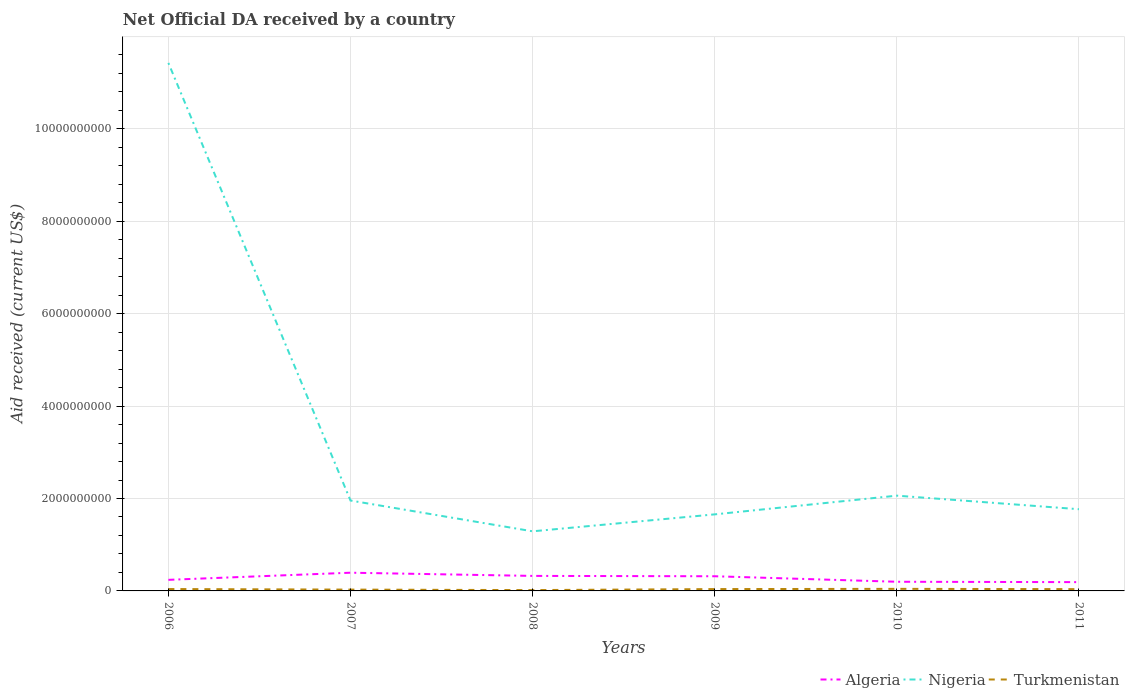How many different coloured lines are there?
Ensure brevity in your answer.  3. Does the line corresponding to Nigeria intersect with the line corresponding to Algeria?
Your answer should be compact. No. Across all years, what is the maximum net official development assistance aid received in Nigeria?
Give a very brief answer. 1.29e+09. What is the total net official development assistance aid received in Algeria in the graph?
Provide a succinct answer. 1.35e+08. What is the difference between the highest and the second highest net official development assistance aid received in Turkmenistan?
Your answer should be compact. 2.65e+07. What is the difference between two consecutive major ticks on the Y-axis?
Offer a very short reply. 2.00e+09. How many legend labels are there?
Keep it short and to the point. 3. How are the legend labels stacked?
Provide a short and direct response. Horizontal. What is the title of the graph?
Keep it short and to the point. Net Official DA received by a country. Does "Dominica" appear as one of the legend labels in the graph?
Ensure brevity in your answer.  No. What is the label or title of the Y-axis?
Provide a succinct answer. Aid received (current US$). What is the Aid received (current US$) of Algeria in 2006?
Your answer should be very brief. 2.40e+08. What is the Aid received (current US$) in Nigeria in 2006?
Offer a terse response. 1.14e+1. What is the Aid received (current US$) of Turkmenistan in 2006?
Your answer should be very brief. 4.07e+07. What is the Aid received (current US$) of Algeria in 2007?
Offer a very short reply. 3.94e+08. What is the Aid received (current US$) of Nigeria in 2007?
Your response must be concise. 1.96e+09. What is the Aid received (current US$) of Turkmenistan in 2007?
Provide a succinct answer. 2.85e+07. What is the Aid received (current US$) in Algeria in 2008?
Ensure brevity in your answer.  3.25e+08. What is the Aid received (current US$) of Nigeria in 2008?
Your answer should be very brief. 1.29e+09. What is the Aid received (current US$) in Turkmenistan in 2008?
Ensure brevity in your answer.  1.81e+07. What is the Aid received (current US$) in Algeria in 2009?
Offer a very short reply. 3.18e+08. What is the Aid received (current US$) of Nigeria in 2009?
Provide a succinct answer. 1.66e+09. What is the Aid received (current US$) in Turkmenistan in 2009?
Your answer should be compact. 3.98e+07. What is the Aid received (current US$) in Algeria in 2010?
Keep it short and to the point. 1.98e+08. What is the Aid received (current US$) of Nigeria in 2010?
Provide a succinct answer. 2.06e+09. What is the Aid received (current US$) in Turkmenistan in 2010?
Offer a terse response. 4.46e+07. What is the Aid received (current US$) in Algeria in 2011?
Offer a terse response. 1.90e+08. What is the Aid received (current US$) of Nigeria in 2011?
Your answer should be very brief. 1.77e+09. What is the Aid received (current US$) of Turkmenistan in 2011?
Provide a succinct answer. 3.87e+07. Across all years, what is the maximum Aid received (current US$) in Algeria?
Offer a very short reply. 3.94e+08. Across all years, what is the maximum Aid received (current US$) of Nigeria?
Make the answer very short. 1.14e+1. Across all years, what is the maximum Aid received (current US$) in Turkmenistan?
Offer a terse response. 4.46e+07. Across all years, what is the minimum Aid received (current US$) of Algeria?
Provide a succinct answer. 1.90e+08. Across all years, what is the minimum Aid received (current US$) in Nigeria?
Provide a succinct answer. 1.29e+09. Across all years, what is the minimum Aid received (current US$) of Turkmenistan?
Provide a short and direct response. 1.81e+07. What is the total Aid received (current US$) of Algeria in the graph?
Provide a short and direct response. 1.67e+09. What is the total Aid received (current US$) of Nigeria in the graph?
Offer a very short reply. 2.02e+1. What is the total Aid received (current US$) of Turkmenistan in the graph?
Keep it short and to the point. 2.10e+08. What is the difference between the Aid received (current US$) in Algeria in 2006 and that in 2007?
Your answer should be very brief. -1.54e+08. What is the difference between the Aid received (current US$) of Nigeria in 2006 and that in 2007?
Make the answer very short. 9.47e+09. What is the difference between the Aid received (current US$) of Turkmenistan in 2006 and that in 2007?
Keep it short and to the point. 1.22e+07. What is the difference between the Aid received (current US$) of Algeria in 2006 and that in 2008?
Keep it short and to the point. -8.51e+07. What is the difference between the Aid received (current US$) in Nigeria in 2006 and that in 2008?
Keep it short and to the point. 1.01e+1. What is the difference between the Aid received (current US$) in Turkmenistan in 2006 and that in 2008?
Ensure brevity in your answer.  2.26e+07. What is the difference between the Aid received (current US$) in Algeria in 2006 and that in 2009?
Offer a terse response. -7.76e+07. What is the difference between the Aid received (current US$) in Nigeria in 2006 and that in 2009?
Your response must be concise. 9.77e+09. What is the difference between the Aid received (current US$) in Turkmenistan in 2006 and that in 2009?
Give a very brief answer. 8.70e+05. What is the difference between the Aid received (current US$) of Algeria in 2006 and that in 2010?
Offer a very short reply. 4.16e+07. What is the difference between the Aid received (current US$) in Nigeria in 2006 and that in 2010?
Make the answer very short. 9.37e+09. What is the difference between the Aid received (current US$) in Turkmenistan in 2006 and that in 2010?
Provide a short and direct response. -3.94e+06. What is the difference between the Aid received (current US$) in Algeria in 2006 and that in 2011?
Give a very brief answer. 4.96e+07. What is the difference between the Aid received (current US$) in Nigeria in 2006 and that in 2011?
Give a very brief answer. 9.66e+09. What is the difference between the Aid received (current US$) in Turkmenistan in 2006 and that in 2011?
Offer a very short reply. 2.03e+06. What is the difference between the Aid received (current US$) in Algeria in 2007 and that in 2008?
Your answer should be compact. 6.92e+07. What is the difference between the Aid received (current US$) of Nigeria in 2007 and that in 2008?
Give a very brief answer. 6.66e+08. What is the difference between the Aid received (current US$) of Turkmenistan in 2007 and that in 2008?
Keep it short and to the point. 1.04e+07. What is the difference between the Aid received (current US$) of Algeria in 2007 and that in 2009?
Make the answer very short. 7.68e+07. What is the difference between the Aid received (current US$) of Nigeria in 2007 and that in 2009?
Make the answer very short. 2.99e+08. What is the difference between the Aid received (current US$) in Turkmenistan in 2007 and that in 2009?
Give a very brief answer. -1.14e+07. What is the difference between the Aid received (current US$) of Algeria in 2007 and that in 2010?
Offer a terse response. 1.96e+08. What is the difference between the Aid received (current US$) of Nigeria in 2007 and that in 2010?
Your response must be concise. -1.06e+08. What is the difference between the Aid received (current US$) in Turkmenistan in 2007 and that in 2010?
Provide a succinct answer. -1.62e+07. What is the difference between the Aid received (current US$) of Algeria in 2007 and that in 2011?
Provide a succinct answer. 2.04e+08. What is the difference between the Aid received (current US$) of Nigeria in 2007 and that in 2011?
Make the answer very short. 1.88e+08. What is the difference between the Aid received (current US$) of Turkmenistan in 2007 and that in 2011?
Your answer should be compact. -1.02e+07. What is the difference between the Aid received (current US$) of Algeria in 2008 and that in 2009?
Offer a terse response. 7.54e+06. What is the difference between the Aid received (current US$) in Nigeria in 2008 and that in 2009?
Give a very brief answer. -3.67e+08. What is the difference between the Aid received (current US$) in Turkmenistan in 2008 and that in 2009?
Your answer should be very brief. -2.17e+07. What is the difference between the Aid received (current US$) of Algeria in 2008 and that in 2010?
Your answer should be compact. 1.27e+08. What is the difference between the Aid received (current US$) in Nigeria in 2008 and that in 2010?
Give a very brief answer. -7.72e+08. What is the difference between the Aid received (current US$) in Turkmenistan in 2008 and that in 2010?
Your answer should be very brief. -2.65e+07. What is the difference between the Aid received (current US$) of Algeria in 2008 and that in 2011?
Keep it short and to the point. 1.35e+08. What is the difference between the Aid received (current US$) in Nigeria in 2008 and that in 2011?
Ensure brevity in your answer.  -4.78e+08. What is the difference between the Aid received (current US$) of Turkmenistan in 2008 and that in 2011?
Provide a succinct answer. -2.06e+07. What is the difference between the Aid received (current US$) of Algeria in 2009 and that in 2010?
Provide a succinct answer. 1.19e+08. What is the difference between the Aid received (current US$) in Nigeria in 2009 and that in 2010?
Provide a succinct answer. -4.05e+08. What is the difference between the Aid received (current US$) in Turkmenistan in 2009 and that in 2010?
Provide a short and direct response. -4.81e+06. What is the difference between the Aid received (current US$) of Algeria in 2009 and that in 2011?
Provide a short and direct response. 1.27e+08. What is the difference between the Aid received (current US$) of Nigeria in 2009 and that in 2011?
Provide a succinct answer. -1.11e+08. What is the difference between the Aid received (current US$) in Turkmenistan in 2009 and that in 2011?
Provide a short and direct response. 1.16e+06. What is the difference between the Aid received (current US$) in Algeria in 2010 and that in 2011?
Your response must be concise. 8.03e+06. What is the difference between the Aid received (current US$) of Nigeria in 2010 and that in 2011?
Make the answer very short. 2.93e+08. What is the difference between the Aid received (current US$) in Turkmenistan in 2010 and that in 2011?
Keep it short and to the point. 5.97e+06. What is the difference between the Aid received (current US$) of Algeria in 2006 and the Aid received (current US$) of Nigeria in 2007?
Provide a short and direct response. -1.72e+09. What is the difference between the Aid received (current US$) of Algeria in 2006 and the Aid received (current US$) of Turkmenistan in 2007?
Provide a succinct answer. 2.11e+08. What is the difference between the Aid received (current US$) of Nigeria in 2006 and the Aid received (current US$) of Turkmenistan in 2007?
Keep it short and to the point. 1.14e+1. What is the difference between the Aid received (current US$) of Algeria in 2006 and the Aid received (current US$) of Nigeria in 2008?
Provide a short and direct response. -1.05e+09. What is the difference between the Aid received (current US$) in Algeria in 2006 and the Aid received (current US$) in Turkmenistan in 2008?
Offer a very short reply. 2.22e+08. What is the difference between the Aid received (current US$) of Nigeria in 2006 and the Aid received (current US$) of Turkmenistan in 2008?
Offer a very short reply. 1.14e+1. What is the difference between the Aid received (current US$) in Algeria in 2006 and the Aid received (current US$) in Nigeria in 2009?
Keep it short and to the point. -1.42e+09. What is the difference between the Aid received (current US$) in Algeria in 2006 and the Aid received (current US$) in Turkmenistan in 2009?
Provide a succinct answer. 2.00e+08. What is the difference between the Aid received (current US$) of Nigeria in 2006 and the Aid received (current US$) of Turkmenistan in 2009?
Provide a short and direct response. 1.14e+1. What is the difference between the Aid received (current US$) of Algeria in 2006 and the Aid received (current US$) of Nigeria in 2010?
Give a very brief answer. -1.82e+09. What is the difference between the Aid received (current US$) in Algeria in 2006 and the Aid received (current US$) in Turkmenistan in 2010?
Keep it short and to the point. 1.95e+08. What is the difference between the Aid received (current US$) in Nigeria in 2006 and the Aid received (current US$) in Turkmenistan in 2010?
Ensure brevity in your answer.  1.14e+1. What is the difference between the Aid received (current US$) in Algeria in 2006 and the Aid received (current US$) in Nigeria in 2011?
Offer a very short reply. -1.53e+09. What is the difference between the Aid received (current US$) in Algeria in 2006 and the Aid received (current US$) in Turkmenistan in 2011?
Offer a terse response. 2.01e+08. What is the difference between the Aid received (current US$) in Nigeria in 2006 and the Aid received (current US$) in Turkmenistan in 2011?
Offer a very short reply. 1.14e+1. What is the difference between the Aid received (current US$) of Algeria in 2007 and the Aid received (current US$) of Nigeria in 2008?
Your response must be concise. -8.96e+08. What is the difference between the Aid received (current US$) in Algeria in 2007 and the Aid received (current US$) in Turkmenistan in 2008?
Offer a terse response. 3.76e+08. What is the difference between the Aid received (current US$) of Nigeria in 2007 and the Aid received (current US$) of Turkmenistan in 2008?
Your answer should be compact. 1.94e+09. What is the difference between the Aid received (current US$) of Algeria in 2007 and the Aid received (current US$) of Nigeria in 2009?
Your answer should be very brief. -1.26e+09. What is the difference between the Aid received (current US$) in Algeria in 2007 and the Aid received (current US$) in Turkmenistan in 2009?
Offer a terse response. 3.54e+08. What is the difference between the Aid received (current US$) of Nigeria in 2007 and the Aid received (current US$) of Turkmenistan in 2009?
Your response must be concise. 1.92e+09. What is the difference between the Aid received (current US$) of Algeria in 2007 and the Aid received (current US$) of Nigeria in 2010?
Offer a terse response. -1.67e+09. What is the difference between the Aid received (current US$) of Algeria in 2007 and the Aid received (current US$) of Turkmenistan in 2010?
Your response must be concise. 3.50e+08. What is the difference between the Aid received (current US$) of Nigeria in 2007 and the Aid received (current US$) of Turkmenistan in 2010?
Ensure brevity in your answer.  1.91e+09. What is the difference between the Aid received (current US$) in Algeria in 2007 and the Aid received (current US$) in Nigeria in 2011?
Offer a terse response. -1.37e+09. What is the difference between the Aid received (current US$) of Algeria in 2007 and the Aid received (current US$) of Turkmenistan in 2011?
Offer a terse response. 3.56e+08. What is the difference between the Aid received (current US$) in Nigeria in 2007 and the Aid received (current US$) in Turkmenistan in 2011?
Offer a very short reply. 1.92e+09. What is the difference between the Aid received (current US$) in Algeria in 2008 and the Aid received (current US$) in Nigeria in 2009?
Provide a short and direct response. -1.33e+09. What is the difference between the Aid received (current US$) of Algeria in 2008 and the Aid received (current US$) of Turkmenistan in 2009?
Provide a short and direct response. 2.85e+08. What is the difference between the Aid received (current US$) of Nigeria in 2008 and the Aid received (current US$) of Turkmenistan in 2009?
Give a very brief answer. 1.25e+09. What is the difference between the Aid received (current US$) in Algeria in 2008 and the Aid received (current US$) in Nigeria in 2010?
Your response must be concise. -1.74e+09. What is the difference between the Aid received (current US$) in Algeria in 2008 and the Aid received (current US$) in Turkmenistan in 2010?
Your answer should be compact. 2.80e+08. What is the difference between the Aid received (current US$) of Nigeria in 2008 and the Aid received (current US$) of Turkmenistan in 2010?
Provide a succinct answer. 1.25e+09. What is the difference between the Aid received (current US$) in Algeria in 2008 and the Aid received (current US$) in Nigeria in 2011?
Your response must be concise. -1.44e+09. What is the difference between the Aid received (current US$) of Algeria in 2008 and the Aid received (current US$) of Turkmenistan in 2011?
Offer a terse response. 2.86e+08. What is the difference between the Aid received (current US$) in Nigeria in 2008 and the Aid received (current US$) in Turkmenistan in 2011?
Ensure brevity in your answer.  1.25e+09. What is the difference between the Aid received (current US$) in Algeria in 2009 and the Aid received (current US$) in Nigeria in 2010?
Offer a terse response. -1.74e+09. What is the difference between the Aid received (current US$) in Algeria in 2009 and the Aid received (current US$) in Turkmenistan in 2010?
Your response must be concise. 2.73e+08. What is the difference between the Aid received (current US$) of Nigeria in 2009 and the Aid received (current US$) of Turkmenistan in 2010?
Ensure brevity in your answer.  1.61e+09. What is the difference between the Aid received (current US$) in Algeria in 2009 and the Aid received (current US$) in Nigeria in 2011?
Offer a terse response. -1.45e+09. What is the difference between the Aid received (current US$) of Algeria in 2009 and the Aid received (current US$) of Turkmenistan in 2011?
Offer a very short reply. 2.79e+08. What is the difference between the Aid received (current US$) of Nigeria in 2009 and the Aid received (current US$) of Turkmenistan in 2011?
Offer a very short reply. 1.62e+09. What is the difference between the Aid received (current US$) in Algeria in 2010 and the Aid received (current US$) in Nigeria in 2011?
Offer a very short reply. -1.57e+09. What is the difference between the Aid received (current US$) in Algeria in 2010 and the Aid received (current US$) in Turkmenistan in 2011?
Your answer should be compact. 1.60e+08. What is the difference between the Aid received (current US$) of Nigeria in 2010 and the Aid received (current US$) of Turkmenistan in 2011?
Keep it short and to the point. 2.02e+09. What is the average Aid received (current US$) of Algeria per year?
Provide a succinct answer. 2.78e+08. What is the average Aid received (current US$) of Nigeria per year?
Your response must be concise. 3.36e+09. What is the average Aid received (current US$) in Turkmenistan per year?
Provide a short and direct response. 3.51e+07. In the year 2006, what is the difference between the Aid received (current US$) in Algeria and Aid received (current US$) in Nigeria?
Provide a short and direct response. -1.12e+1. In the year 2006, what is the difference between the Aid received (current US$) of Algeria and Aid received (current US$) of Turkmenistan?
Your response must be concise. 1.99e+08. In the year 2006, what is the difference between the Aid received (current US$) in Nigeria and Aid received (current US$) in Turkmenistan?
Provide a succinct answer. 1.14e+1. In the year 2007, what is the difference between the Aid received (current US$) of Algeria and Aid received (current US$) of Nigeria?
Give a very brief answer. -1.56e+09. In the year 2007, what is the difference between the Aid received (current US$) in Algeria and Aid received (current US$) in Turkmenistan?
Your answer should be very brief. 3.66e+08. In the year 2007, what is the difference between the Aid received (current US$) of Nigeria and Aid received (current US$) of Turkmenistan?
Keep it short and to the point. 1.93e+09. In the year 2008, what is the difference between the Aid received (current US$) of Algeria and Aid received (current US$) of Nigeria?
Your answer should be very brief. -9.65e+08. In the year 2008, what is the difference between the Aid received (current US$) in Algeria and Aid received (current US$) in Turkmenistan?
Give a very brief answer. 3.07e+08. In the year 2008, what is the difference between the Aid received (current US$) in Nigeria and Aid received (current US$) in Turkmenistan?
Your answer should be compact. 1.27e+09. In the year 2009, what is the difference between the Aid received (current US$) in Algeria and Aid received (current US$) in Nigeria?
Provide a succinct answer. -1.34e+09. In the year 2009, what is the difference between the Aid received (current US$) of Algeria and Aid received (current US$) of Turkmenistan?
Your answer should be compact. 2.78e+08. In the year 2009, what is the difference between the Aid received (current US$) in Nigeria and Aid received (current US$) in Turkmenistan?
Offer a very short reply. 1.62e+09. In the year 2010, what is the difference between the Aid received (current US$) in Algeria and Aid received (current US$) in Nigeria?
Offer a terse response. -1.86e+09. In the year 2010, what is the difference between the Aid received (current US$) in Algeria and Aid received (current US$) in Turkmenistan?
Provide a short and direct response. 1.54e+08. In the year 2010, what is the difference between the Aid received (current US$) of Nigeria and Aid received (current US$) of Turkmenistan?
Your response must be concise. 2.02e+09. In the year 2011, what is the difference between the Aid received (current US$) in Algeria and Aid received (current US$) in Nigeria?
Provide a short and direct response. -1.58e+09. In the year 2011, what is the difference between the Aid received (current US$) in Algeria and Aid received (current US$) in Turkmenistan?
Your answer should be very brief. 1.52e+08. In the year 2011, what is the difference between the Aid received (current US$) of Nigeria and Aid received (current US$) of Turkmenistan?
Provide a succinct answer. 1.73e+09. What is the ratio of the Aid received (current US$) of Algeria in 2006 to that in 2007?
Provide a succinct answer. 0.61. What is the ratio of the Aid received (current US$) of Nigeria in 2006 to that in 2007?
Offer a very short reply. 5.84. What is the ratio of the Aid received (current US$) in Turkmenistan in 2006 to that in 2007?
Provide a short and direct response. 1.43. What is the ratio of the Aid received (current US$) of Algeria in 2006 to that in 2008?
Ensure brevity in your answer.  0.74. What is the ratio of the Aid received (current US$) of Nigeria in 2006 to that in 2008?
Ensure brevity in your answer.  8.86. What is the ratio of the Aid received (current US$) of Turkmenistan in 2006 to that in 2008?
Keep it short and to the point. 2.25. What is the ratio of the Aid received (current US$) in Algeria in 2006 to that in 2009?
Your answer should be compact. 0.76. What is the ratio of the Aid received (current US$) in Nigeria in 2006 to that in 2009?
Offer a terse response. 6.9. What is the ratio of the Aid received (current US$) in Turkmenistan in 2006 to that in 2009?
Give a very brief answer. 1.02. What is the ratio of the Aid received (current US$) of Algeria in 2006 to that in 2010?
Provide a succinct answer. 1.21. What is the ratio of the Aid received (current US$) of Nigeria in 2006 to that in 2010?
Keep it short and to the point. 5.54. What is the ratio of the Aid received (current US$) of Turkmenistan in 2006 to that in 2010?
Provide a succinct answer. 0.91. What is the ratio of the Aid received (current US$) in Algeria in 2006 to that in 2011?
Your answer should be very brief. 1.26. What is the ratio of the Aid received (current US$) of Nigeria in 2006 to that in 2011?
Offer a terse response. 6.46. What is the ratio of the Aid received (current US$) of Turkmenistan in 2006 to that in 2011?
Provide a succinct answer. 1.05. What is the ratio of the Aid received (current US$) of Algeria in 2007 to that in 2008?
Provide a succinct answer. 1.21. What is the ratio of the Aid received (current US$) of Nigeria in 2007 to that in 2008?
Offer a terse response. 1.52. What is the ratio of the Aid received (current US$) in Turkmenistan in 2007 to that in 2008?
Give a very brief answer. 1.57. What is the ratio of the Aid received (current US$) of Algeria in 2007 to that in 2009?
Provide a succinct answer. 1.24. What is the ratio of the Aid received (current US$) of Nigeria in 2007 to that in 2009?
Provide a succinct answer. 1.18. What is the ratio of the Aid received (current US$) in Turkmenistan in 2007 to that in 2009?
Give a very brief answer. 0.71. What is the ratio of the Aid received (current US$) in Algeria in 2007 to that in 2010?
Ensure brevity in your answer.  1.99. What is the ratio of the Aid received (current US$) in Nigeria in 2007 to that in 2010?
Offer a terse response. 0.95. What is the ratio of the Aid received (current US$) in Turkmenistan in 2007 to that in 2010?
Ensure brevity in your answer.  0.64. What is the ratio of the Aid received (current US$) of Algeria in 2007 to that in 2011?
Offer a very short reply. 2.07. What is the ratio of the Aid received (current US$) of Nigeria in 2007 to that in 2011?
Provide a short and direct response. 1.11. What is the ratio of the Aid received (current US$) in Turkmenistan in 2007 to that in 2011?
Your answer should be compact. 0.74. What is the ratio of the Aid received (current US$) of Algeria in 2008 to that in 2009?
Your answer should be very brief. 1.02. What is the ratio of the Aid received (current US$) in Nigeria in 2008 to that in 2009?
Ensure brevity in your answer.  0.78. What is the ratio of the Aid received (current US$) in Turkmenistan in 2008 to that in 2009?
Your answer should be very brief. 0.46. What is the ratio of the Aid received (current US$) of Algeria in 2008 to that in 2010?
Your answer should be very brief. 1.64. What is the ratio of the Aid received (current US$) of Nigeria in 2008 to that in 2010?
Offer a terse response. 0.63. What is the ratio of the Aid received (current US$) in Turkmenistan in 2008 to that in 2010?
Make the answer very short. 0.41. What is the ratio of the Aid received (current US$) in Algeria in 2008 to that in 2011?
Your answer should be very brief. 1.71. What is the ratio of the Aid received (current US$) in Nigeria in 2008 to that in 2011?
Offer a very short reply. 0.73. What is the ratio of the Aid received (current US$) of Turkmenistan in 2008 to that in 2011?
Your answer should be compact. 0.47. What is the ratio of the Aid received (current US$) in Algeria in 2009 to that in 2010?
Give a very brief answer. 1.6. What is the ratio of the Aid received (current US$) in Nigeria in 2009 to that in 2010?
Provide a short and direct response. 0.8. What is the ratio of the Aid received (current US$) in Turkmenistan in 2009 to that in 2010?
Keep it short and to the point. 0.89. What is the ratio of the Aid received (current US$) of Algeria in 2009 to that in 2011?
Keep it short and to the point. 1.67. What is the ratio of the Aid received (current US$) in Nigeria in 2009 to that in 2011?
Provide a succinct answer. 0.94. What is the ratio of the Aid received (current US$) of Algeria in 2010 to that in 2011?
Give a very brief answer. 1.04. What is the ratio of the Aid received (current US$) in Nigeria in 2010 to that in 2011?
Make the answer very short. 1.17. What is the ratio of the Aid received (current US$) in Turkmenistan in 2010 to that in 2011?
Provide a short and direct response. 1.15. What is the difference between the highest and the second highest Aid received (current US$) of Algeria?
Make the answer very short. 6.92e+07. What is the difference between the highest and the second highest Aid received (current US$) of Nigeria?
Ensure brevity in your answer.  9.37e+09. What is the difference between the highest and the second highest Aid received (current US$) of Turkmenistan?
Make the answer very short. 3.94e+06. What is the difference between the highest and the lowest Aid received (current US$) of Algeria?
Offer a terse response. 2.04e+08. What is the difference between the highest and the lowest Aid received (current US$) in Nigeria?
Give a very brief answer. 1.01e+1. What is the difference between the highest and the lowest Aid received (current US$) in Turkmenistan?
Give a very brief answer. 2.65e+07. 